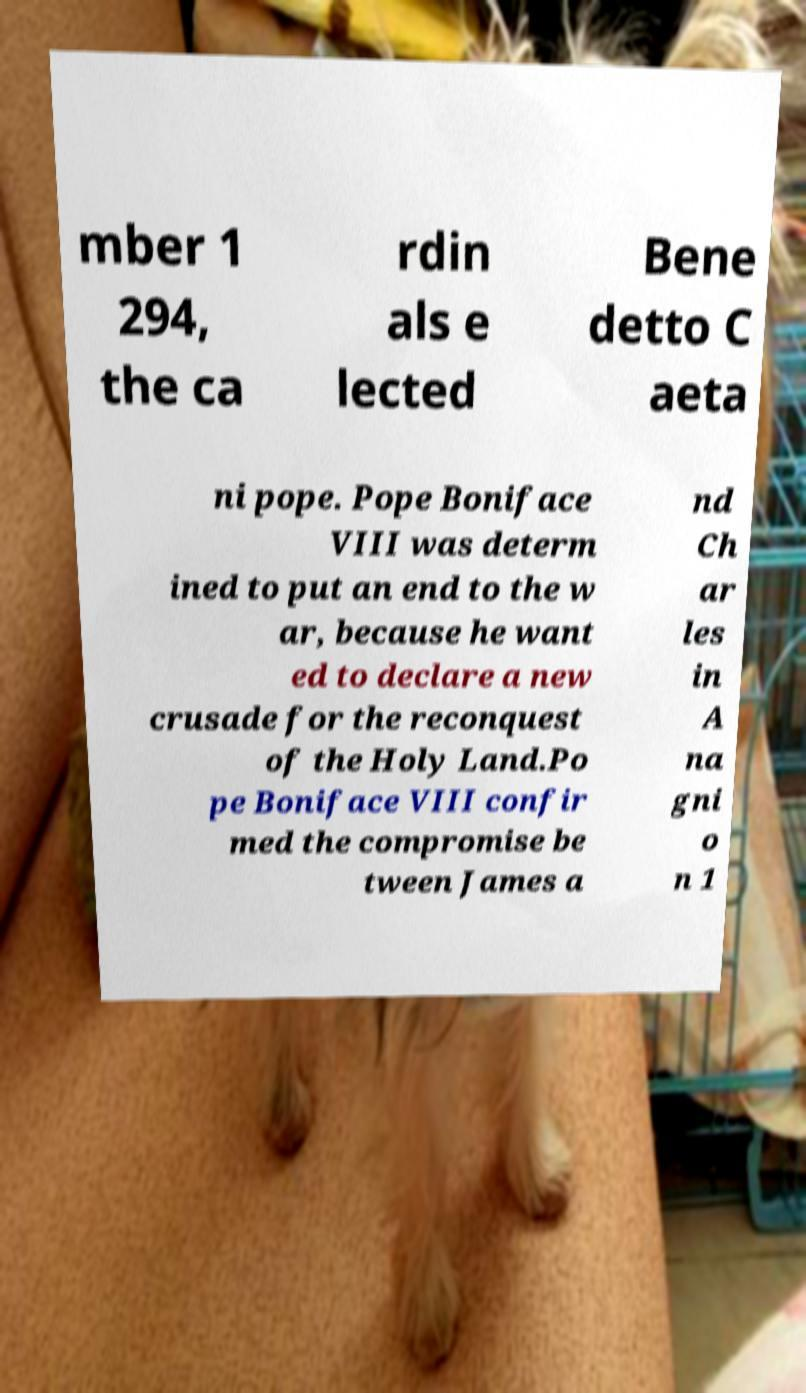For documentation purposes, I need the text within this image transcribed. Could you provide that? mber 1 294, the ca rdin als e lected Bene detto C aeta ni pope. Pope Boniface VIII was determ ined to put an end to the w ar, because he want ed to declare a new crusade for the reconquest of the Holy Land.Po pe Boniface VIII confir med the compromise be tween James a nd Ch ar les in A na gni o n 1 